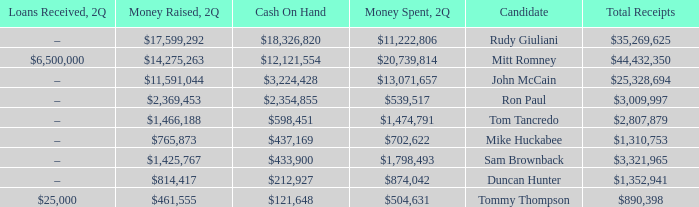Name the loans received for 2Q having total receipts of $25,328,694 –. 